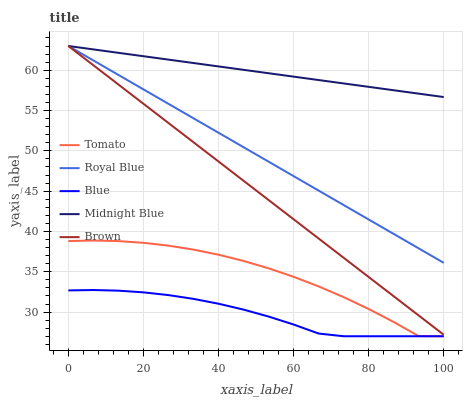Does Blue have the minimum area under the curve?
Answer yes or no. Yes. Does Midnight Blue have the maximum area under the curve?
Answer yes or no. Yes. Does Royal Blue have the minimum area under the curve?
Answer yes or no. No. Does Royal Blue have the maximum area under the curve?
Answer yes or no. No. Is Brown the smoothest?
Answer yes or no. Yes. Is Tomato the roughest?
Answer yes or no. Yes. Is Royal Blue the smoothest?
Answer yes or no. No. Is Royal Blue the roughest?
Answer yes or no. No. Does Royal Blue have the lowest value?
Answer yes or no. No. Does Brown have the highest value?
Answer yes or no. Yes. Does Blue have the highest value?
Answer yes or no. No. Is Tomato less than Brown?
Answer yes or no. Yes. Is Brown greater than Tomato?
Answer yes or no. Yes. Does Midnight Blue intersect Royal Blue?
Answer yes or no. Yes. Is Midnight Blue less than Royal Blue?
Answer yes or no. No. Is Midnight Blue greater than Royal Blue?
Answer yes or no. No. Does Tomato intersect Brown?
Answer yes or no. No. 